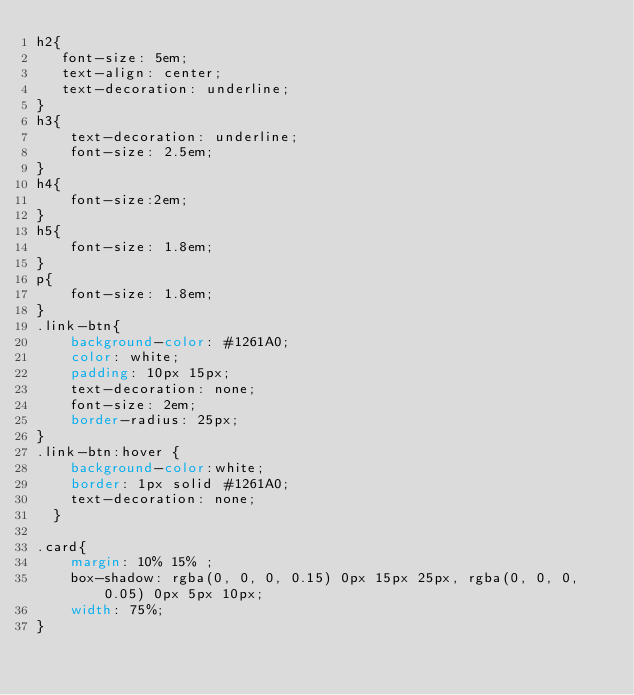<code> <loc_0><loc_0><loc_500><loc_500><_CSS_>h2{
   font-size: 5em;
   text-align: center;
   text-decoration: underline; 
}
h3{
    text-decoration: underline;
    font-size: 2.5em;
}
h4{
    font-size:2em;
}
h5{
    font-size: 1.8em;
}
p{
    font-size: 1.8em;
}
.link-btn{
    background-color: #1261A0;
    color: white;
    padding: 10px 15px;
    text-decoration: none;
    font-size: 2em;
    border-radius: 25px;
}
.link-btn:hover {
    background-color:white;
    border: 1px solid #1261A0;
    text-decoration: none;
  }

.card{
    margin: 10% 15% ;
    box-shadow: rgba(0, 0, 0, 0.15) 0px 15px 25px, rgba(0, 0, 0, 0.05) 0px 5px 10px;
    width: 75%;
}

</code> 